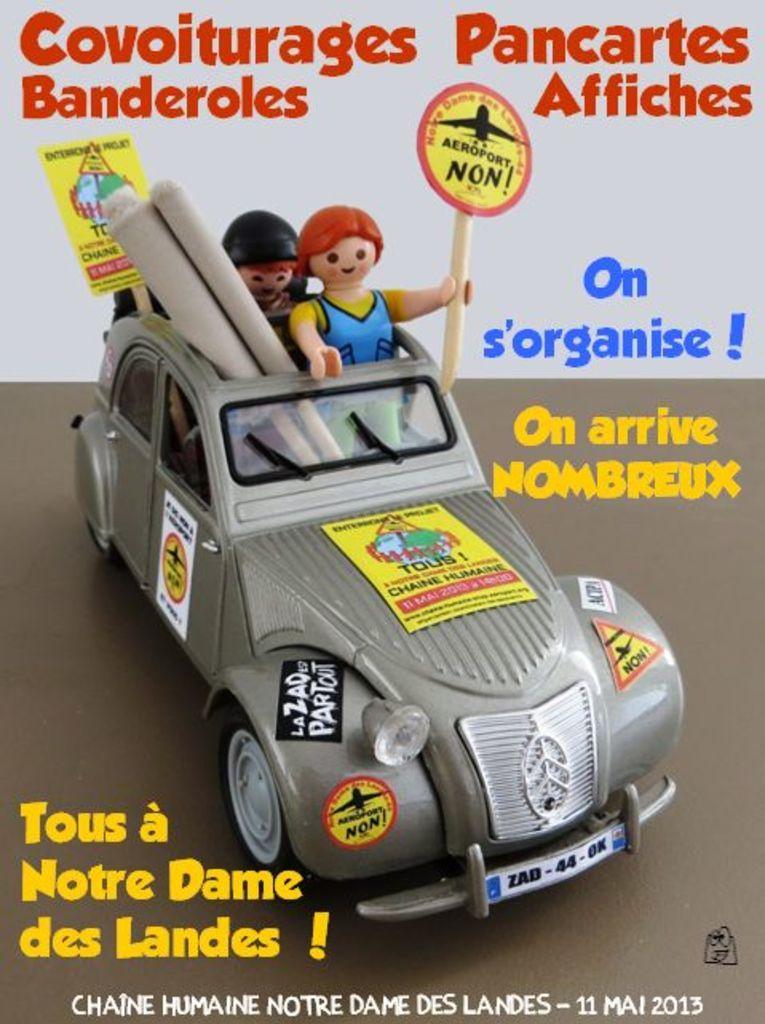Could you give a brief overview of what you see in this image? In this image I can see few toys in the centre. I can also see something is written on the top, in the centre and on the bottom side of this image. 